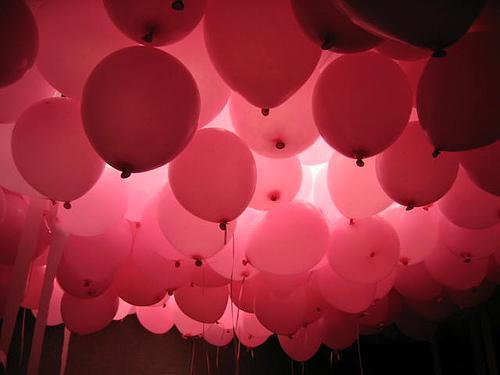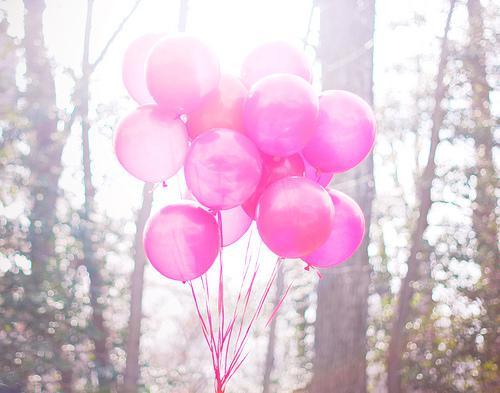The first image is the image on the left, the second image is the image on the right. Considering the images on both sides, is "In one of the images a seated child is near many balloons." valid? Answer yes or no. No. The first image is the image on the left, the second image is the image on the right. For the images shown, is this caption "There is a group of pink balloons together with trees in the background in the right image." true? Answer yes or no. Yes. 